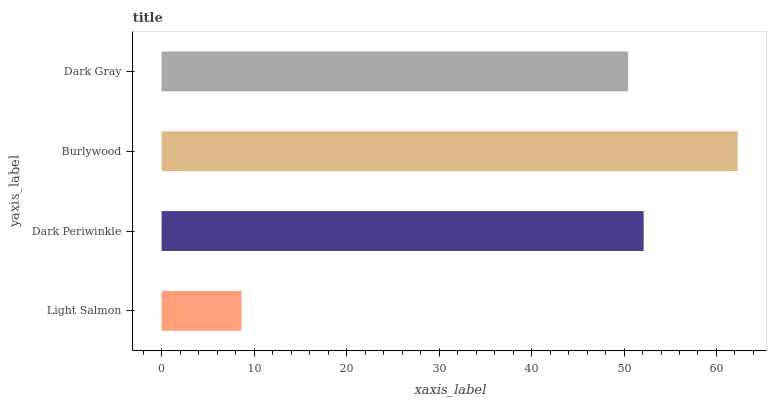Is Light Salmon the minimum?
Answer yes or no. Yes. Is Burlywood the maximum?
Answer yes or no. Yes. Is Dark Periwinkle the minimum?
Answer yes or no. No. Is Dark Periwinkle the maximum?
Answer yes or no. No. Is Dark Periwinkle greater than Light Salmon?
Answer yes or no. Yes. Is Light Salmon less than Dark Periwinkle?
Answer yes or no. Yes. Is Light Salmon greater than Dark Periwinkle?
Answer yes or no. No. Is Dark Periwinkle less than Light Salmon?
Answer yes or no. No. Is Dark Periwinkle the high median?
Answer yes or no. Yes. Is Dark Gray the low median?
Answer yes or no. Yes. Is Burlywood the high median?
Answer yes or no. No. Is Burlywood the low median?
Answer yes or no. No. 